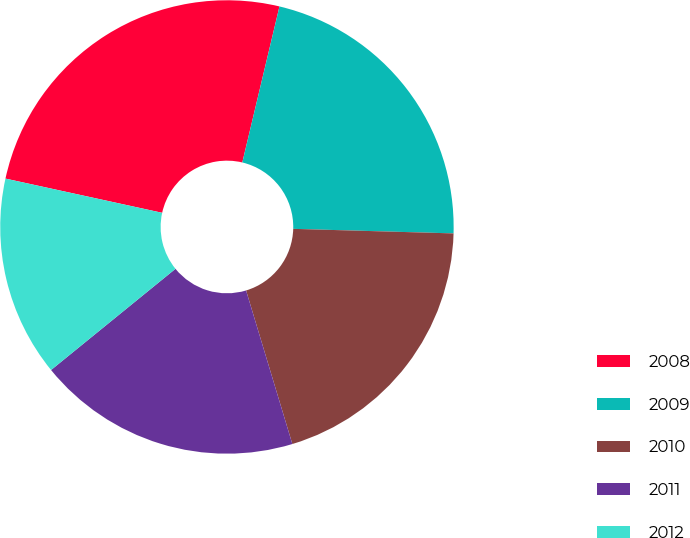Convert chart to OTSL. <chart><loc_0><loc_0><loc_500><loc_500><pie_chart><fcel>2008<fcel>2009<fcel>2010<fcel>2011<fcel>2012<nl><fcel>25.3%<fcel>21.73%<fcel>19.89%<fcel>18.79%<fcel>14.29%<nl></chart> 